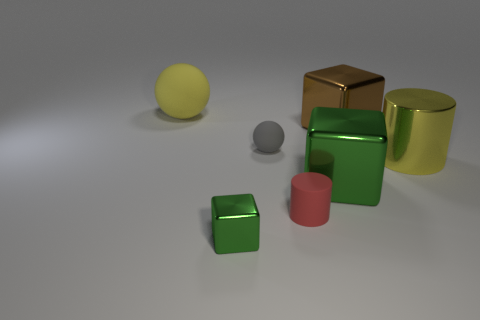There is a large cylinder to the right of the yellow rubber ball; does it have the same color as the large matte thing?
Provide a short and direct response. Yes. Is there any other thing of the same color as the small shiny thing?
Provide a short and direct response. Yes. There is a large object that is the same color as the tiny block; what shape is it?
Ensure brevity in your answer.  Cube. There is a metallic object in front of the red rubber thing; is it the same shape as the big metal thing that is left of the brown cube?
Offer a very short reply. Yes. Is the shape of the tiny red rubber thing the same as the yellow thing that is right of the small red cylinder?
Make the answer very short. Yes. There is a red matte thing that is the same shape as the big yellow shiny object; what is its size?
Give a very brief answer. Small. There is a large sphere; does it have the same color as the cylinder that is right of the brown thing?
Your answer should be very brief. Yes. There is a rubber thing in front of the large metallic cube that is in front of the block behind the large cylinder; what is its shape?
Give a very brief answer. Cylinder. There is a yellow metal thing; is it the same size as the cylinder in front of the metal cylinder?
Offer a very short reply. No. What is the color of the large thing that is both to the left of the brown cube and in front of the brown thing?
Your answer should be very brief. Green. 